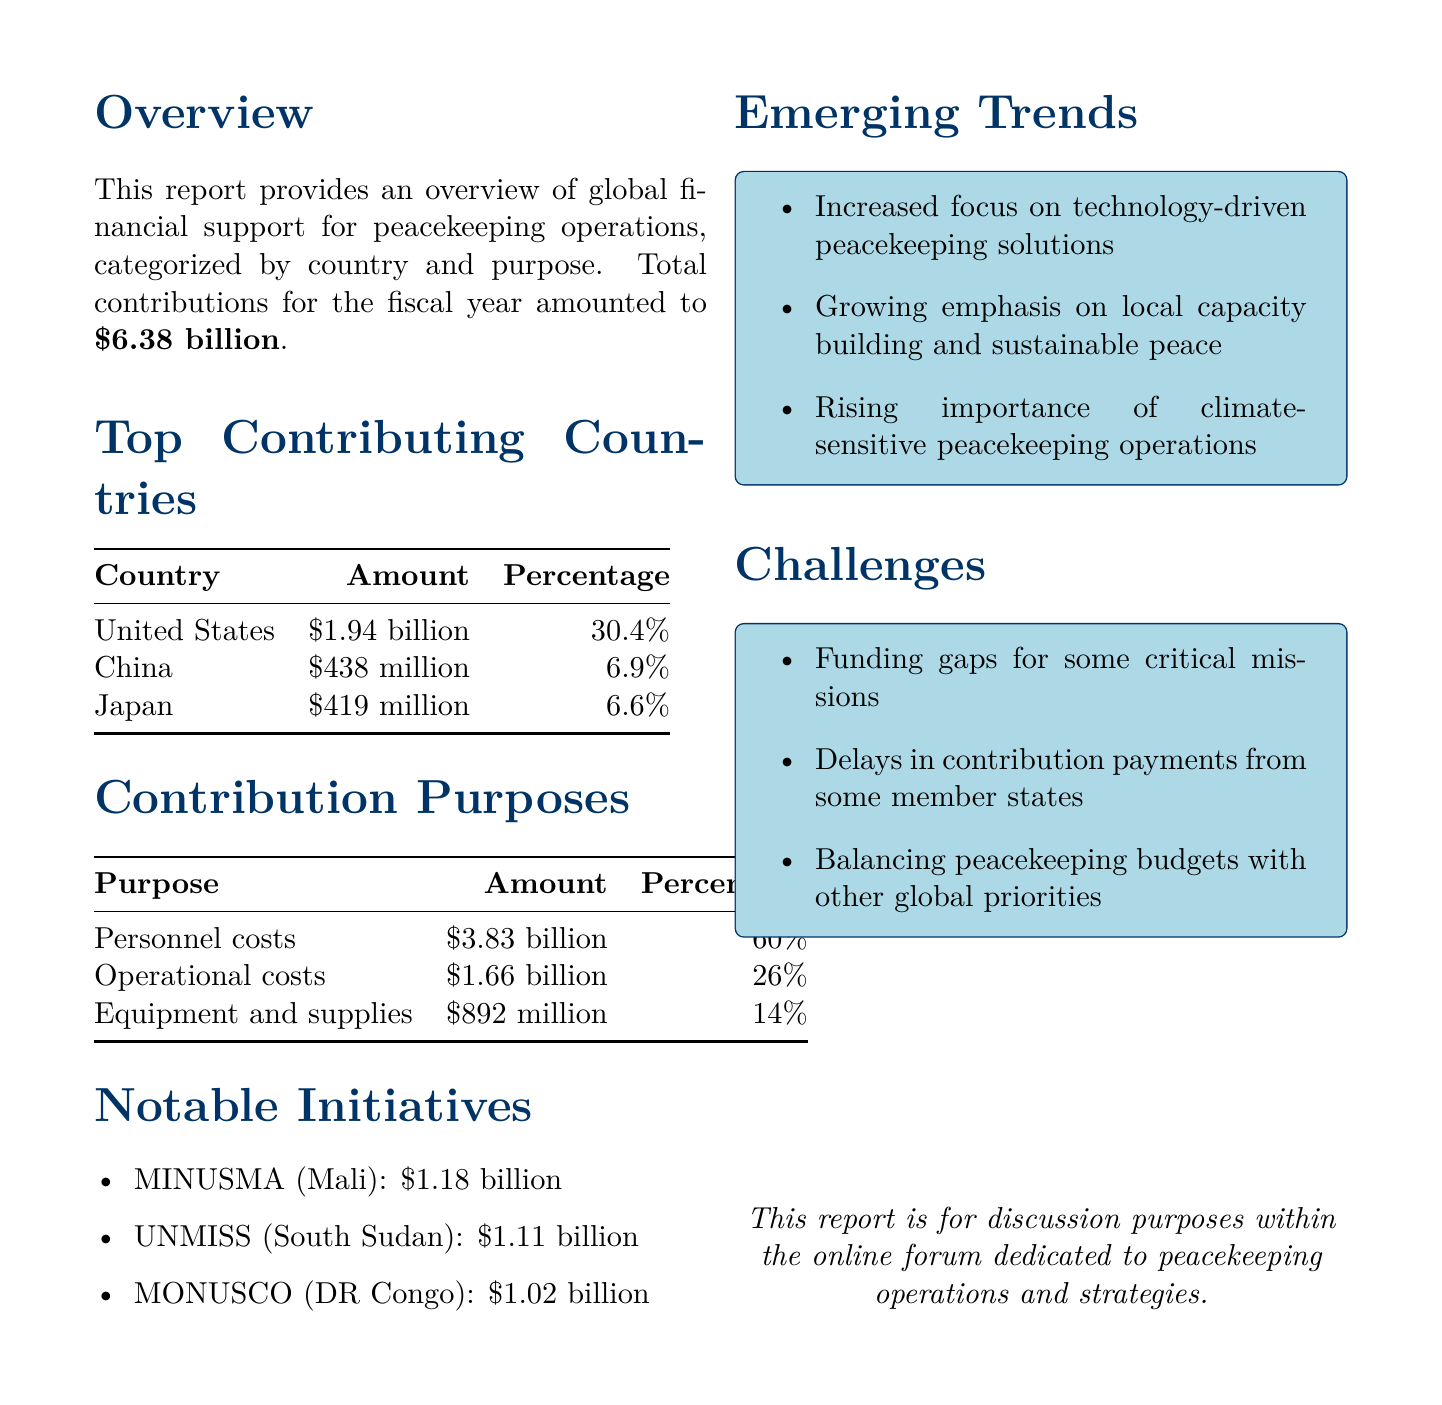What is the total amount of donor contributions? The total amount of donor contributions mentioned in the report is listed clearly, summing up to $6.38 billion.
Answer: $6.38 billion Which country contributed the most to peacekeeping initiatives? The top contributing country is identified in the report, with the United States leading the contributions with $1.94 billion.
Answer: United States What percentage of the total contributions did personnel costs account for? The report provides a detailed breakdown of contributions by purpose, indicating that personnel costs represent 60% of the total contributions.
Answer: 60% What was the budget for UNMISS in South Sudan? The budget for notable initiatives is specified in the report, with UNMISS's budget defined as $1.11 billion.
Answer: $1.11 billion What emerging trend is noted regarding peacekeeping operations? The report highlights several emerging trends, including an increased focus on technology-driven solutions in peacekeeping operations.
Answer: Technology-driven solutions How much of the total contributions was allocated for equipment and supplies? The report categorizes the contributions, noting that $892 million is allocated for equipment and supplies.
Answer: $892 million Which country is the second-largest contributor? The report lists the top contributing countries, identifying China as the second-largest contributor with an amount of $438 million.
Answer: China What is one of the challenges mentioned in the report? The challenges faced in funding peacekeeping missions are addressed, including funding gaps for some critical missions.
Answer: Funding gaps 